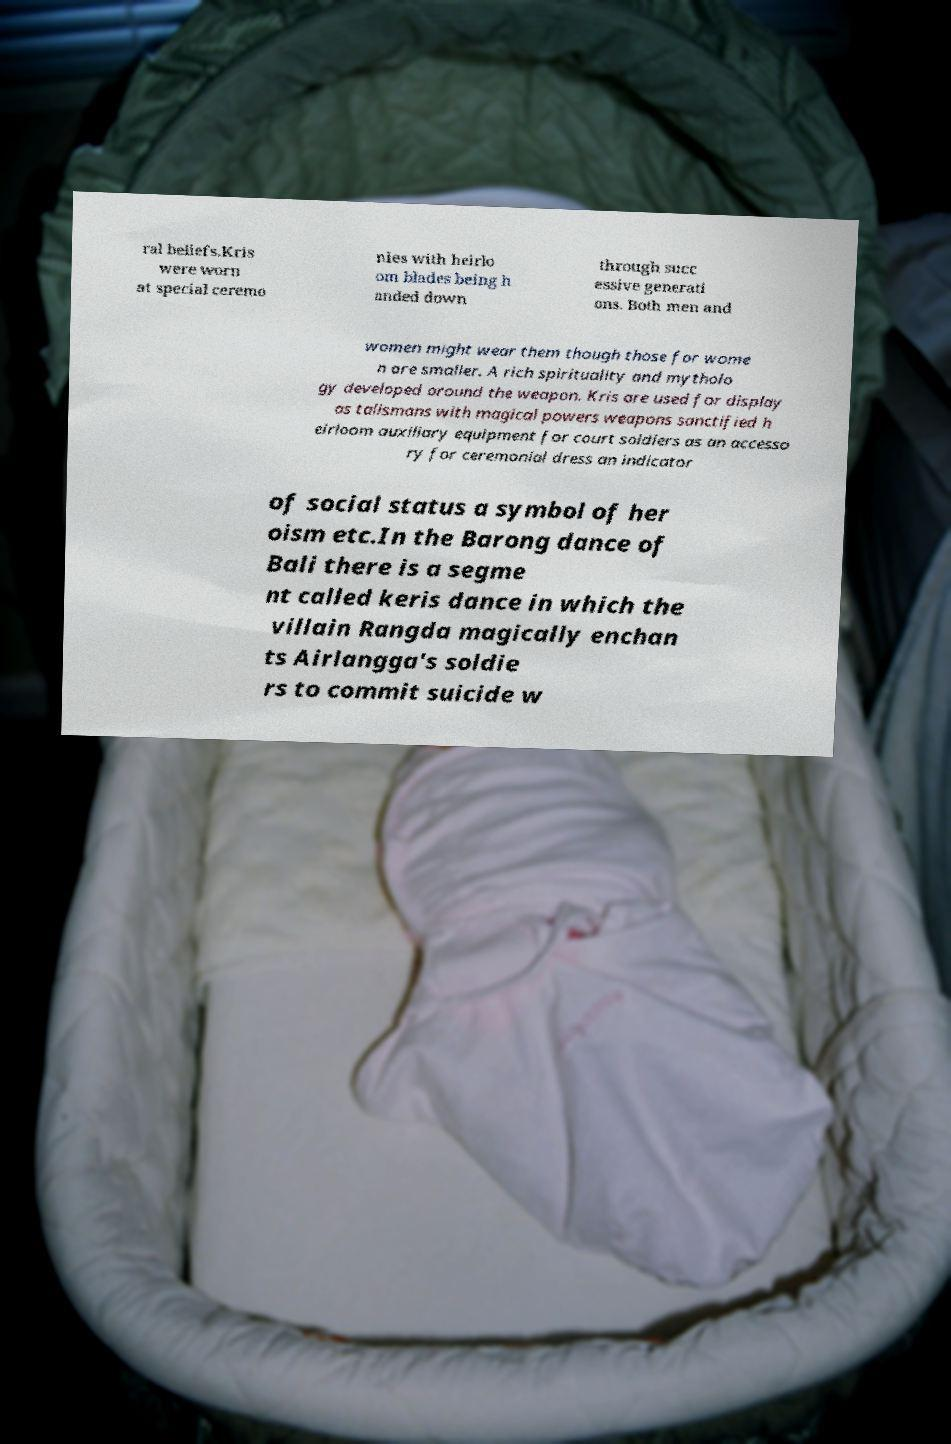For documentation purposes, I need the text within this image transcribed. Could you provide that? ral beliefs.Kris were worn at special ceremo nies with heirlo om blades being h anded down through succ essive generati ons. Both men and women might wear them though those for wome n are smaller. A rich spirituality and mytholo gy developed around the weapon. Kris are used for display as talismans with magical powers weapons sanctified h eirloom auxiliary equipment for court soldiers as an accesso ry for ceremonial dress an indicator of social status a symbol of her oism etc.In the Barong dance of Bali there is a segme nt called keris dance in which the villain Rangda magically enchan ts Airlangga's soldie rs to commit suicide w 